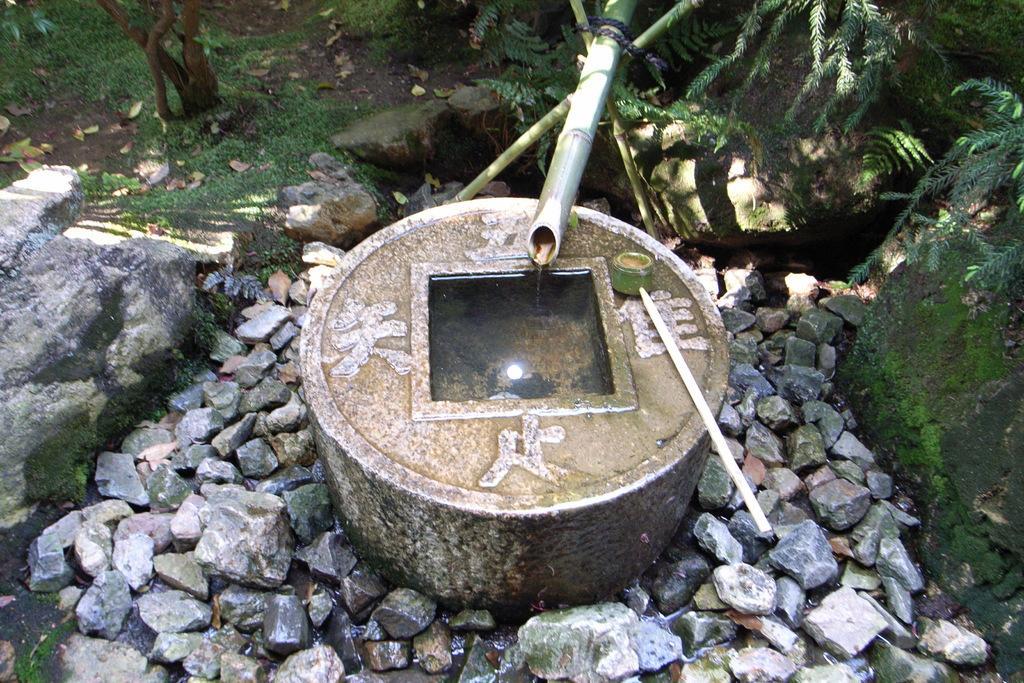Describe this image in one or two sentences. In the center of the image there is a stone structure with some text on it. At the bottom of the image there are stones. In the background of the image there are plants grass and dried leaves. 